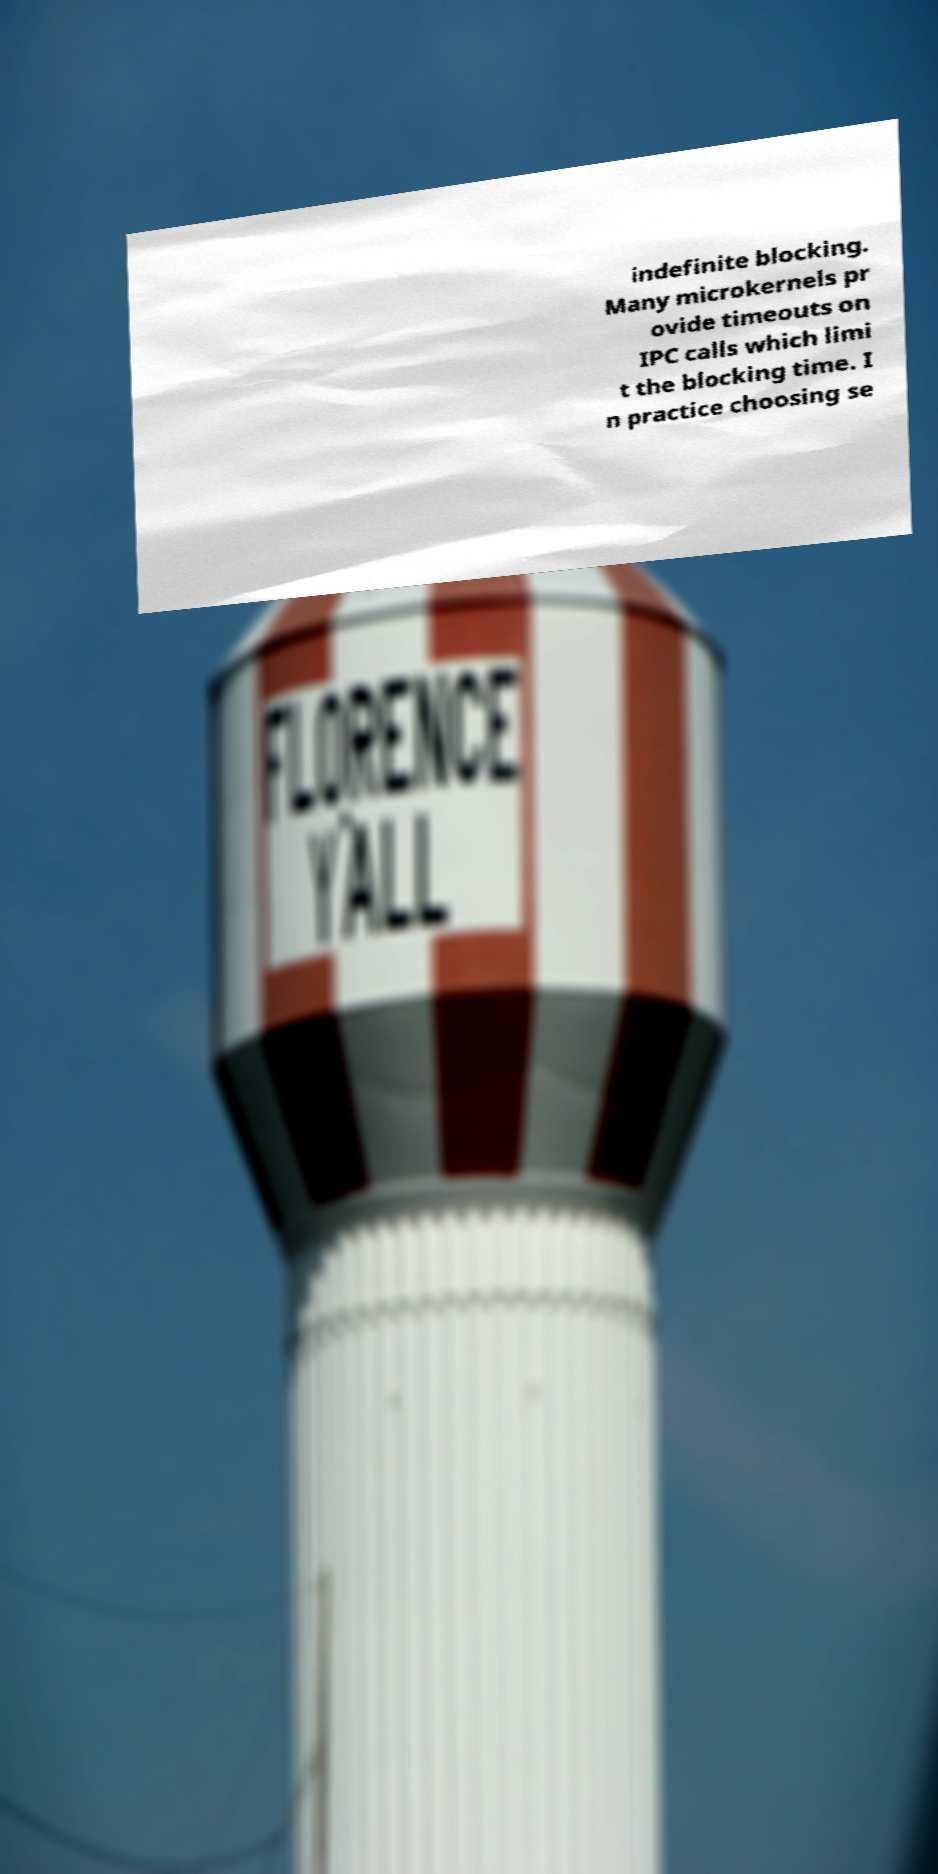I need the written content from this picture converted into text. Can you do that? indefinite blocking. Many microkernels pr ovide timeouts on IPC calls which limi t the blocking time. I n practice choosing se 